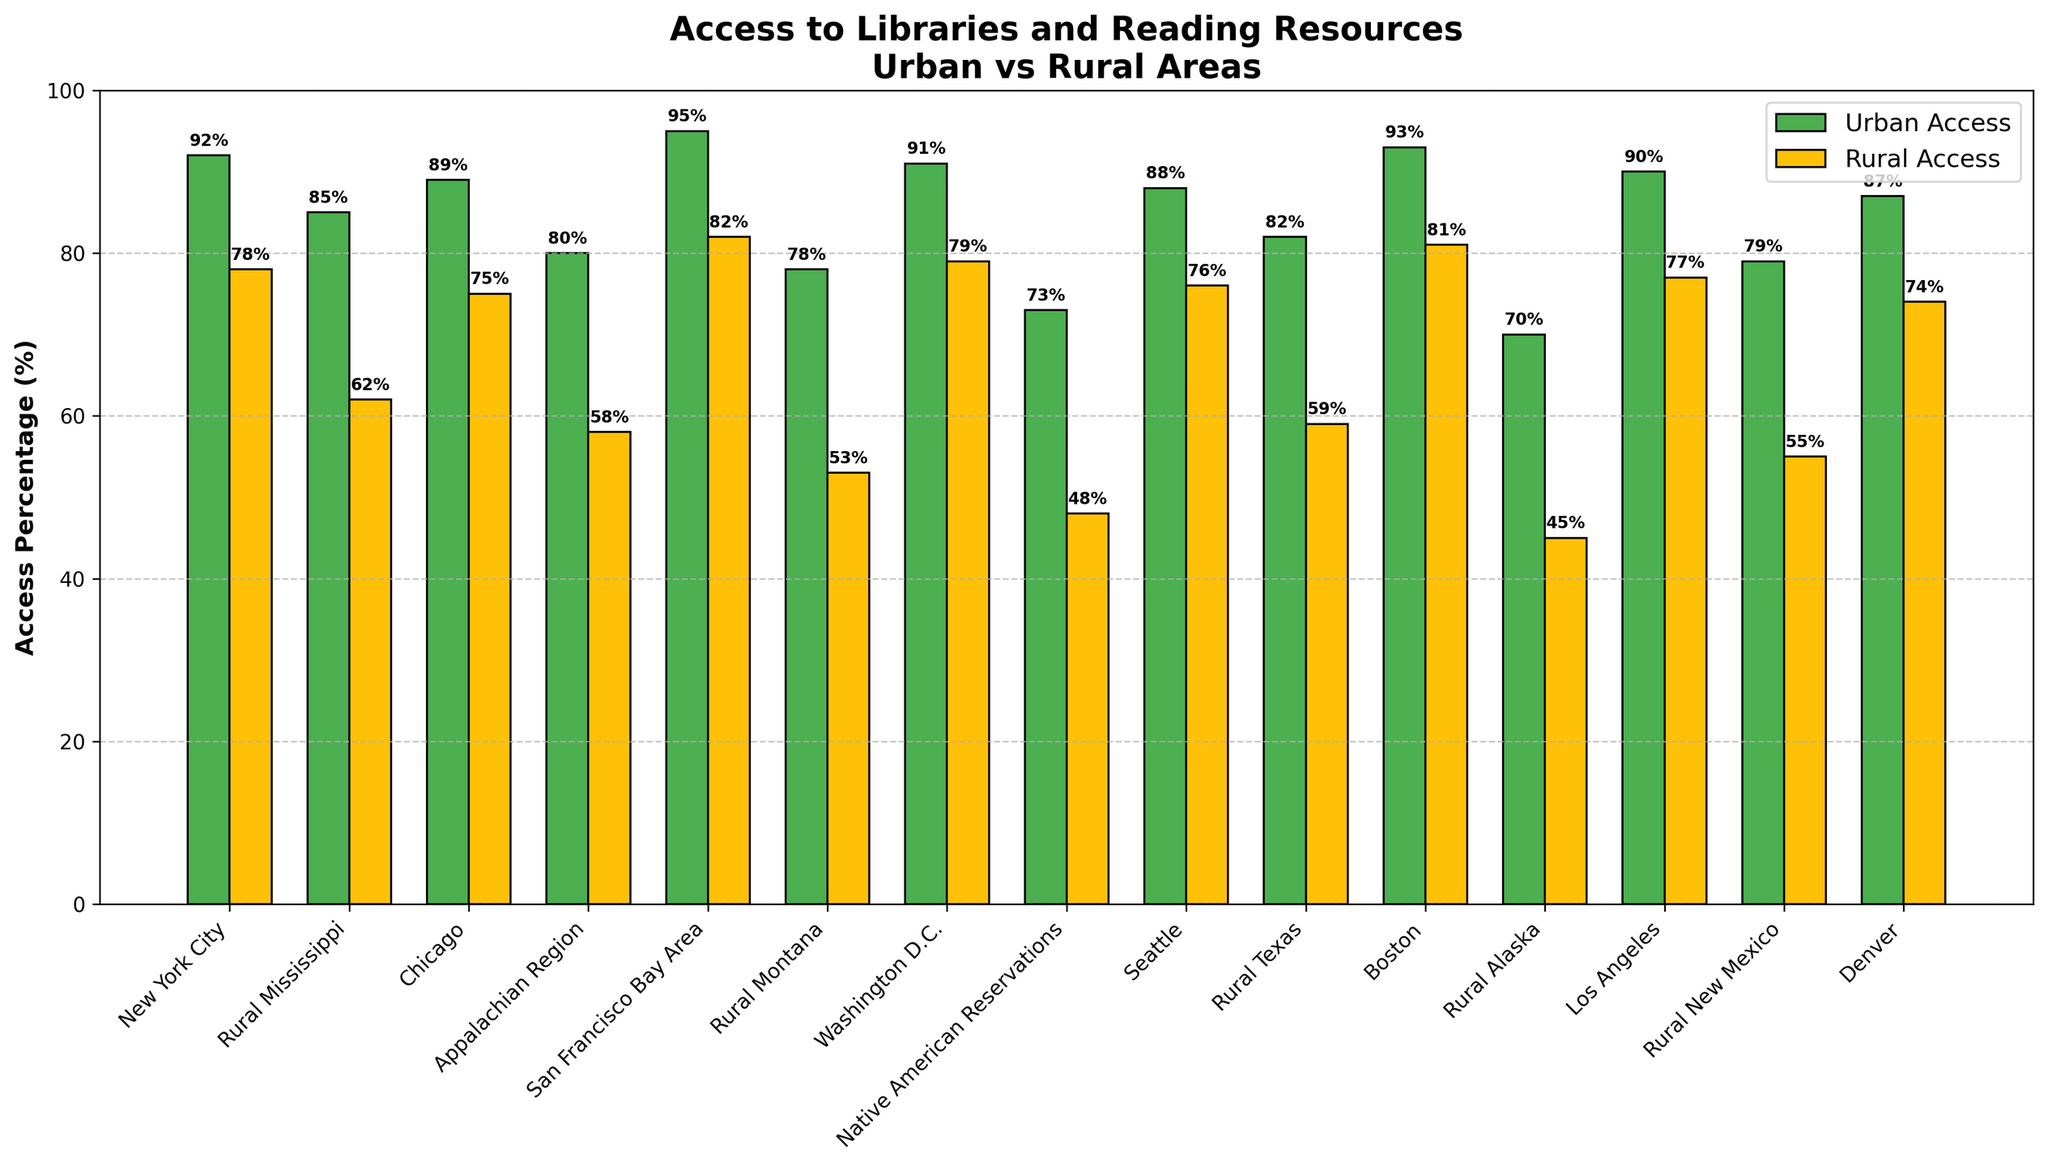How much higher is urban access in New York City compared to rural access in New York City? The figure shows the urban access in New York City is 92% and rural access is 78%. The difference is calculated by subtracting rural access from urban access: 92% - 78% = 14%.
Answer: 14% Which area has the lowest rural access percentage? By inspecting the heights of the yellow bars representing rural access across all areas, Native American Reservations has the lowest rural access percentage at 48%.
Answer: Native American Reservations Is the urban access in San Francisco Bay Area higher than in Washington D.C.? The green bar for urban access in San Francisco Bay Area shows 95%, while Washington D.C. shows 91%. Comparing these values, urban access in San Francisco Bay Area is higher.
Answer: Yes Calculate the average rural access percentage across all areas listed. Adding up the rural access percentages and dividing by the number of areas: (78 + 62 + 75 + 58 + 82 + 53 + 79 + 48 + 76 + 59 + 81 + 45 + 77 + 55 + 74) / 15. This equals 1024 / 15, which is approximately 68.27%.
Answer: 68.27% Which areas have urban access percentages greater than 90%? By examining the height of the green bars for values greater than 90%, New York City (92%), San Francisco Bay Area (95%), Boston (93%), and Los Angeles (90%) have urban access greater than 90%.
Answer: New York City, San Francisco Bay Area, Boston, Los Angeles Is there any location where rural access exceeds 80%? From the figure, the highest rural access percentage observed is in San Francisco Bay Area at 82%, so yes, there is one such location.
Answer: Yes What is the difference in rural access between Rural Montana and Rural Alaska? The rural access for Rural Montana is 53% and for Rural Alaska is 45%. Subtract the values: 53% - 45% = 8%.
Answer: 8% Compare the urban and rural access percentages for Denver. Are they closer or further apart compared to Chicago? In Denver, urban access is 87% and rural access is 74%, so the difference is 87% - 74% = 13%. In Chicago, urban access is 89% and rural access is 75%, so the difference is 89% - 75% = 14%. The access percentages in Denver are closer (13% difference) compared to Chicago (14% difference).
Answer: Closer Which location has the greatest disparity between urban and rural access percentages? By examining and comparing the differences between urban and rural access percentages visually, Native American Reservations has the greatest disparity with an urban access of 73% and rural access of 48%. The difference is 25%.
Answer: Native American Reservations What is the combined urban access percentage for Boston and Seattle? Urban access for Boston is 93%, and for Seattle is 88%. Adding these percentages: 93% + 88% = 181%.
Answer: 181% 